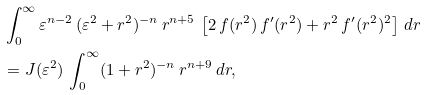<formula> <loc_0><loc_0><loc_500><loc_500>& \int _ { 0 } ^ { \infty } \varepsilon ^ { n - 2 } \, ( \varepsilon ^ { 2 } + r ^ { 2 } ) ^ { - n } \, r ^ { n + 5 } \, \left [ 2 \, f ( r ^ { 2 } ) \, f ^ { \prime } ( r ^ { 2 } ) + r ^ { 2 } \, f ^ { \prime } ( r ^ { 2 } ) ^ { 2 } \right ] \, d r \\ & = J ( \varepsilon ^ { 2 } ) \, \int _ { 0 } ^ { \infty } ( 1 + r ^ { 2 } ) ^ { - n } \, r ^ { n + 9 } \, d r ,</formula> 